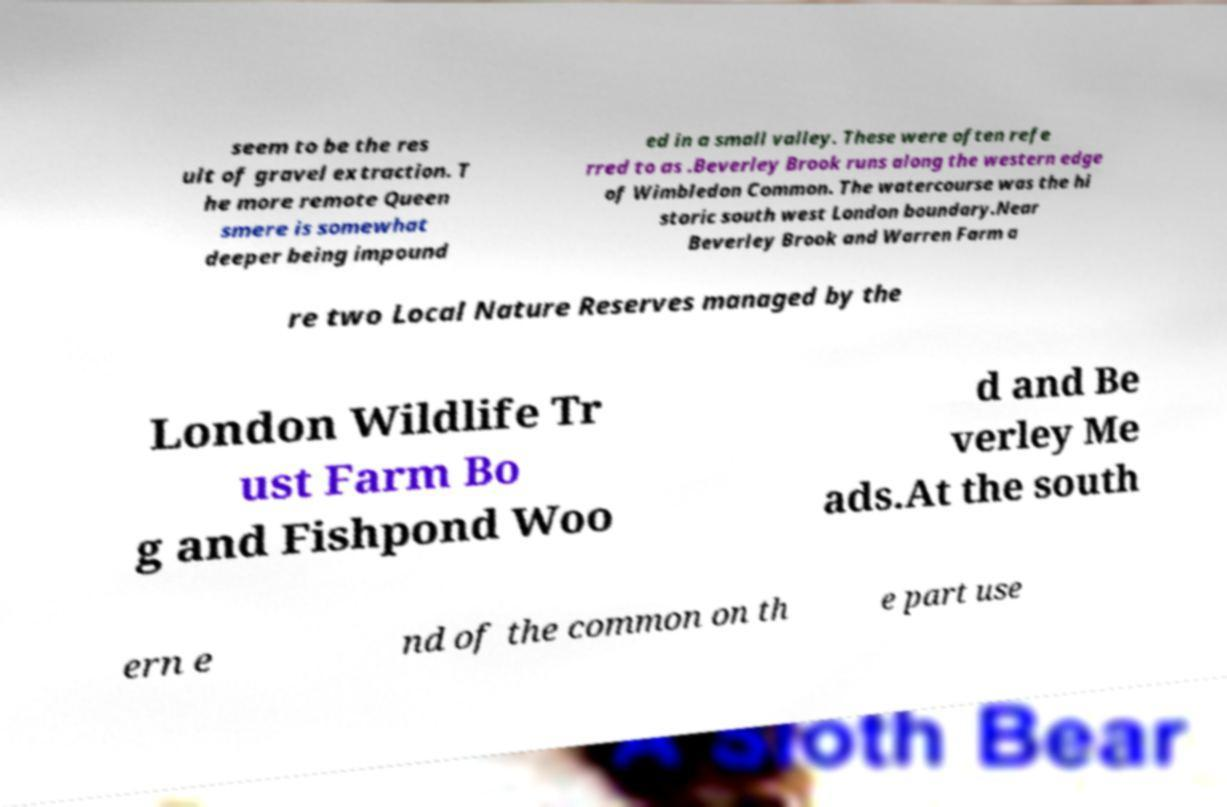Could you extract and type out the text from this image? seem to be the res ult of gravel extraction. T he more remote Queen smere is somewhat deeper being impound ed in a small valley. These were often refe rred to as .Beverley Brook runs along the western edge of Wimbledon Common. The watercourse was the hi storic south west London boundary.Near Beverley Brook and Warren Farm a re two Local Nature Reserves managed by the London Wildlife Tr ust Farm Bo g and Fishpond Woo d and Be verley Me ads.At the south ern e nd of the common on th e part use 